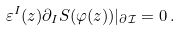<formula> <loc_0><loc_0><loc_500><loc_500>\varepsilon ^ { I } ( z ) \partial _ { I } S ( \varphi ( z ) ) | _ { \partial \mathcal { I } } = 0 \, .</formula> 